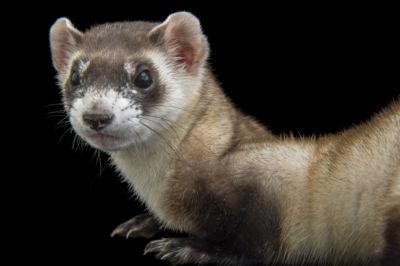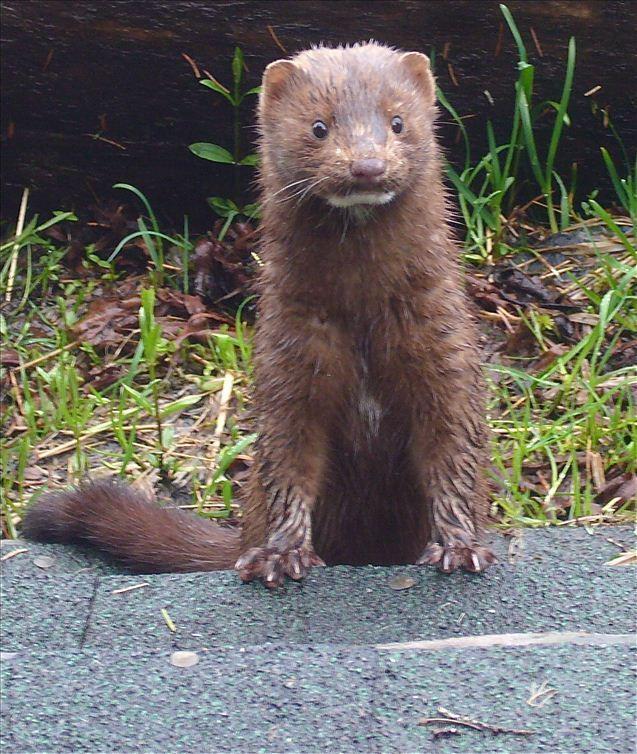The first image is the image on the left, the second image is the image on the right. Assess this claim about the two images: "There are more animals in the image on the right.". Correct or not? Answer yes or no. No. The first image is the image on the left, the second image is the image on the right. Given the left and right images, does the statement "The right image contains at least two ferrets." hold true? Answer yes or no. No. 